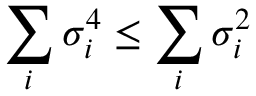<formula> <loc_0><loc_0><loc_500><loc_500>\sum _ { i } \sigma _ { i } ^ { 4 } \leq \sum _ { i } \sigma _ { i } ^ { 2 }</formula> 